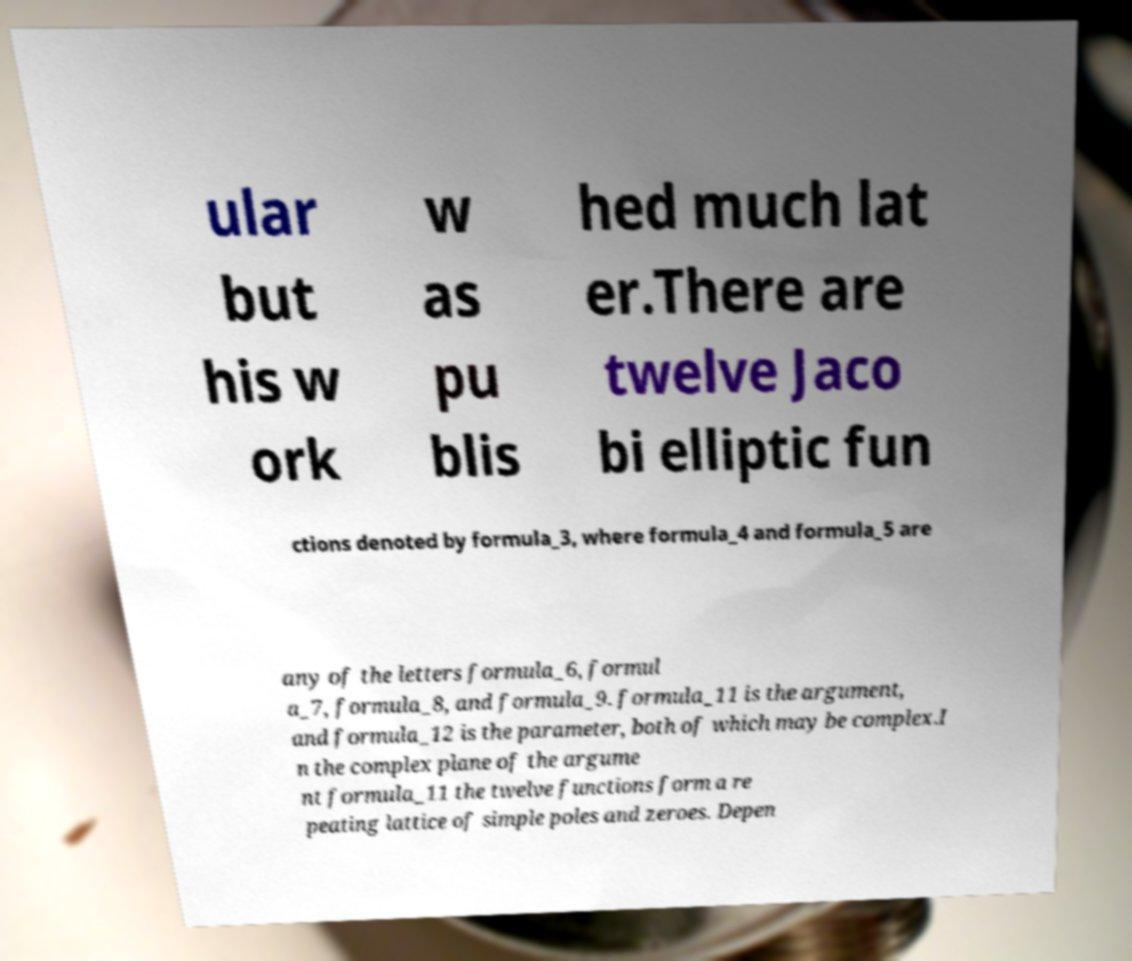Could you extract and type out the text from this image? ular but his w ork w as pu blis hed much lat er.There are twelve Jaco bi elliptic fun ctions denoted by formula_3, where formula_4 and formula_5 are any of the letters formula_6, formul a_7, formula_8, and formula_9. formula_11 is the argument, and formula_12 is the parameter, both of which may be complex.I n the complex plane of the argume nt formula_11 the twelve functions form a re peating lattice of simple poles and zeroes. Depen 